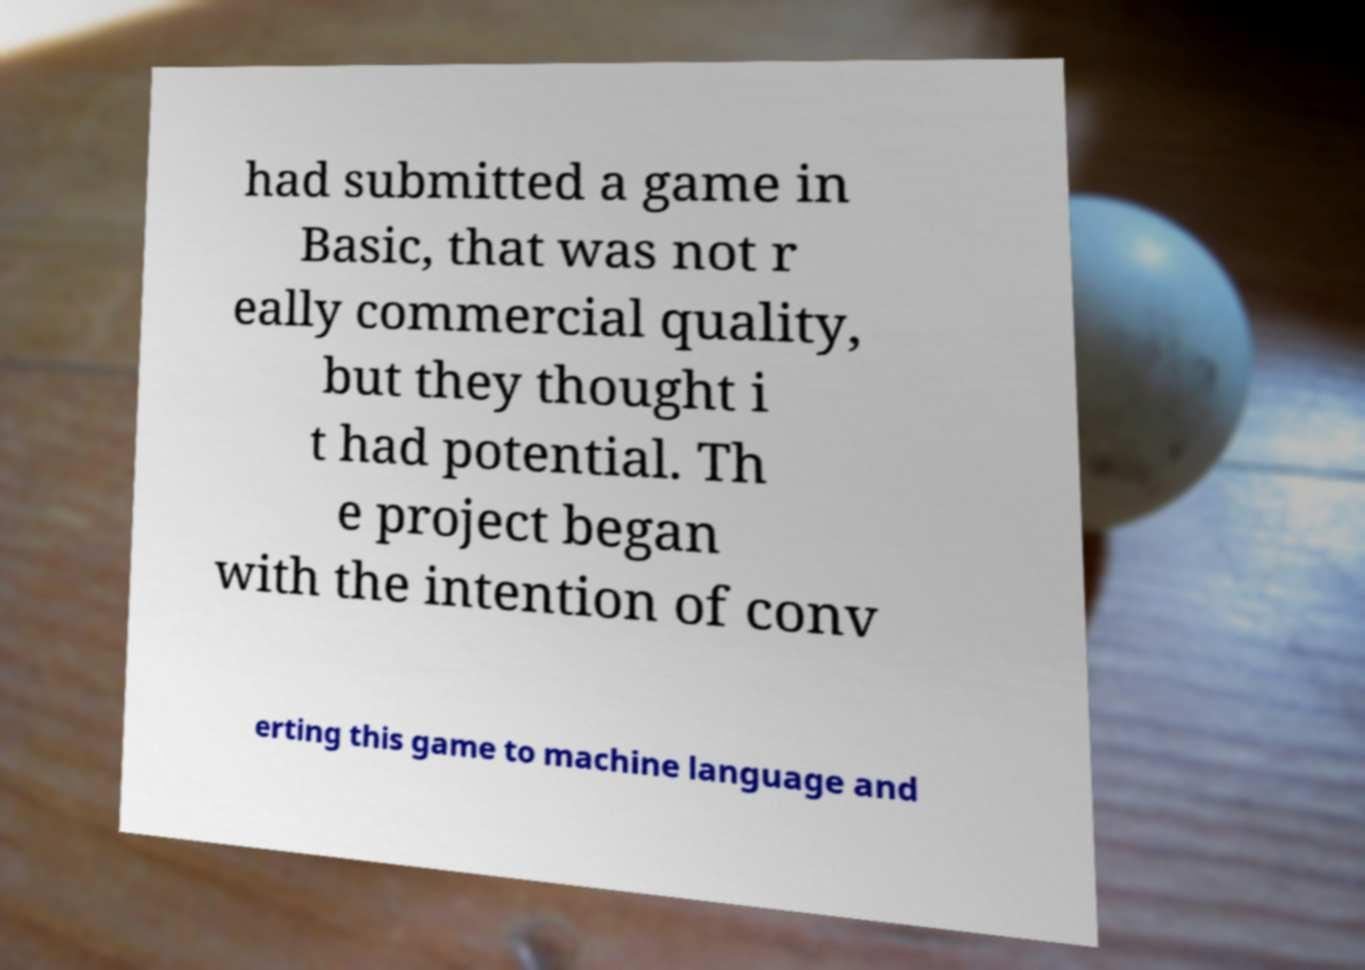Can you accurately transcribe the text from the provided image for me? had submitted a game in Basic, that was not r eally commercial quality, but they thought i t had potential. Th e project began with the intention of conv erting this game to machine language and 